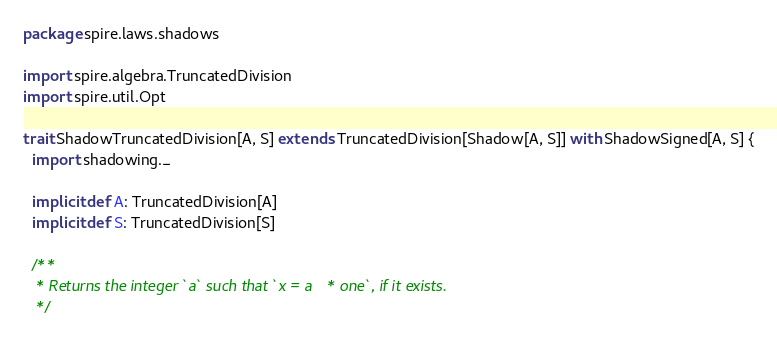<code> <loc_0><loc_0><loc_500><loc_500><_Scala_>package spire.laws.shadows

import spire.algebra.TruncatedDivision
import spire.util.Opt

trait ShadowTruncatedDivision[A, S] extends TruncatedDivision[Shadow[A, S]] with ShadowSigned[A, S] {
  import shadowing._

  implicit def A: TruncatedDivision[A]
  implicit def S: TruncatedDivision[S]

  /**
   * Returns the integer `a` such that `x = a * one`, if it exists.
   */</code> 